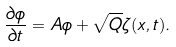<formula> <loc_0><loc_0><loc_500><loc_500>\frac { \partial \phi } { \partial t } = A \phi + \sqrt { Q } \zeta ( x , t ) .</formula> 